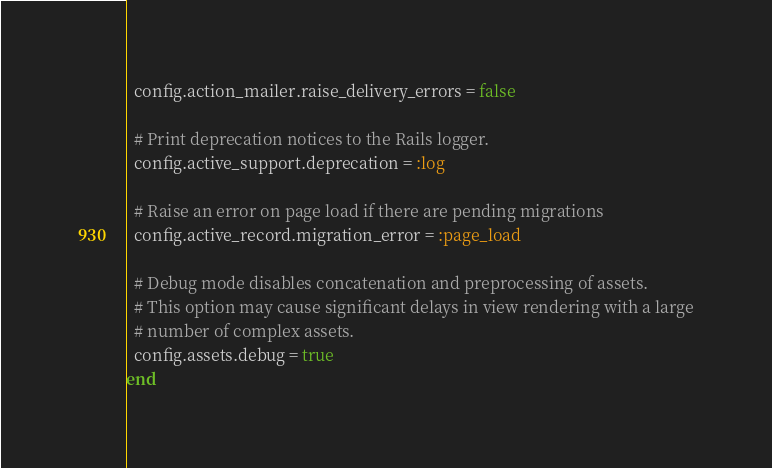<code> <loc_0><loc_0><loc_500><loc_500><_Ruby_>  config.action_mailer.raise_delivery_errors = false

  # Print deprecation notices to the Rails logger.
  config.active_support.deprecation = :log

  # Raise an error on page load if there are pending migrations
  config.active_record.migration_error = :page_load

  # Debug mode disables concatenation and preprocessing of assets.
  # This option may cause significant delays in view rendering with a large
  # number of complex assets.
  config.assets.debug = true
end
</code> 